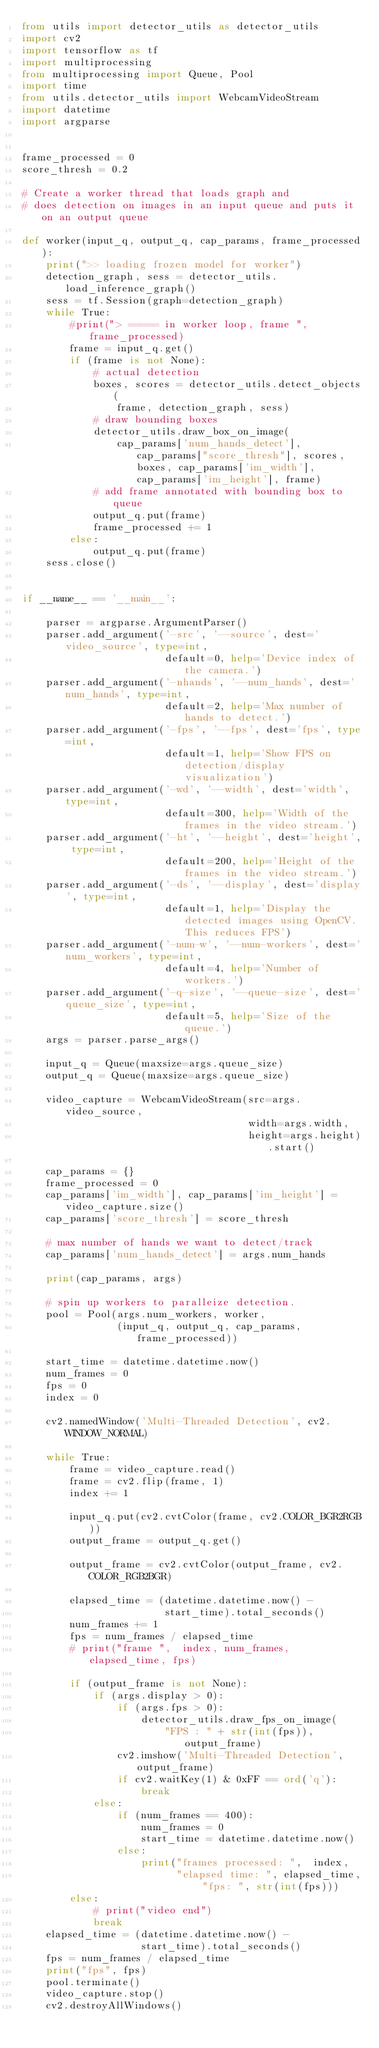Convert code to text. <code><loc_0><loc_0><loc_500><loc_500><_Python_>from utils import detector_utils as detector_utils 
import cv2
import tensorflow as tf
import multiprocessing
from multiprocessing import Queue, Pool
import time
from utils.detector_utils import WebcamVideoStream
import datetime
import argparse


frame_processed = 0
score_thresh = 0.2

# Create a worker thread that loads graph and
# does detection on images in an input queue and puts it on an output queue

def worker(input_q, output_q, cap_params, frame_processed):
    print(">> loading frozen model for worker")
    detection_graph, sess = detector_utils.load_inference_graph()
    sess = tf.Session(graph=detection_graph)
    while True:
        #print("> ===== in worker loop, frame ", frame_processed)
        frame = input_q.get()
        if (frame is not None):
            # actual detection
            boxes, scores = detector_utils.detect_objects(
                frame, detection_graph, sess)
            # draw bounding boxes
            detector_utils.draw_box_on_image(
                cap_params['num_hands_detect'], cap_params["score_thresh"], scores, boxes, cap_params['im_width'], cap_params['im_height'], frame)
            # add frame annotated with bounding box to queue
            output_q.put(frame)
            frame_processed += 1
        else:
            output_q.put(frame)
    sess.close()


if __name__ == '__main__':

    parser = argparse.ArgumentParser()
    parser.add_argument('-src', '--source', dest='video_source', type=int,
                        default=0, help='Device index of the camera.')
    parser.add_argument('-nhands', '--num_hands', dest='num_hands', type=int,
                        default=2, help='Max number of hands to detect.')
    parser.add_argument('-fps', '--fps', dest='fps', type=int,
                        default=1, help='Show FPS on detection/display visualization')
    parser.add_argument('-wd', '--width', dest='width', type=int,
                        default=300, help='Width of the frames in the video stream.')
    parser.add_argument('-ht', '--height', dest='height', type=int,
                        default=200, help='Height of the frames in the video stream.')
    parser.add_argument('-ds', '--display', dest='display', type=int,
                        default=1, help='Display the detected images using OpenCV. This reduces FPS')
    parser.add_argument('-num-w', '--num-workers', dest='num_workers', type=int,
                        default=4, help='Number of workers.')
    parser.add_argument('-q-size', '--queue-size', dest='queue_size', type=int,
                        default=5, help='Size of the queue.')
    args = parser.parse_args()

    input_q = Queue(maxsize=args.queue_size)
    output_q = Queue(maxsize=args.queue_size)

    video_capture = WebcamVideoStream(src=args.video_source,
                                      width=args.width,
                                      height=args.height).start()

    cap_params = {}
    frame_processed = 0
    cap_params['im_width'], cap_params['im_height'] = video_capture.size()
    cap_params['score_thresh'] = score_thresh

    # max number of hands we want to detect/track
    cap_params['num_hands_detect'] = args.num_hands

    print(cap_params, args)

    # spin up workers to paralleize detection.
    pool = Pool(args.num_workers, worker,
                (input_q, output_q, cap_params, frame_processed))

    start_time = datetime.datetime.now()
    num_frames = 0
    fps = 0
    index = 0

    cv2.namedWindow('Multi-Threaded Detection', cv2.WINDOW_NORMAL)

    while True:
        frame = video_capture.read()
        frame = cv2.flip(frame, 1)
        index += 1

        input_q.put(cv2.cvtColor(frame, cv2.COLOR_BGR2RGB))
        output_frame = output_q.get()

        output_frame = cv2.cvtColor(output_frame, cv2.COLOR_RGB2BGR)

        elapsed_time = (datetime.datetime.now() -
                        start_time).total_seconds()
        num_frames += 1
        fps = num_frames / elapsed_time
        # print("frame ",  index, num_frames, elapsed_time, fps)

        if (output_frame is not None):
            if (args.display > 0):
                if (args.fps > 0):
                    detector_utils.draw_fps_on_image(
                        "FPS : " + str(int(fps)), output_frame)
                cv2.imshow('Multi-Threaded Detection', output_frame)
                if cv2.waitKey(1) & 0xFF == ord('q'):
                    break
            else:
                if (num_frames == 400):
                    num_frames = 0
                    start_time = datetime.datetime.now()
                else:
                    print("frames processed: ",  index,
                          "elapsed time: ", elapsed_time, "fps: ", str(int(fps)))
        else:
            # print("video end")
            break
    elapsed_time = (datetime.datetime.now() -
                    start_time).total_seconds()
    fps = num_frames / elapsed_time
    print("fps", fps)
    pool.terminate()
    video_capture.stop()
    cv2.destroyAllWindows()
</code> 